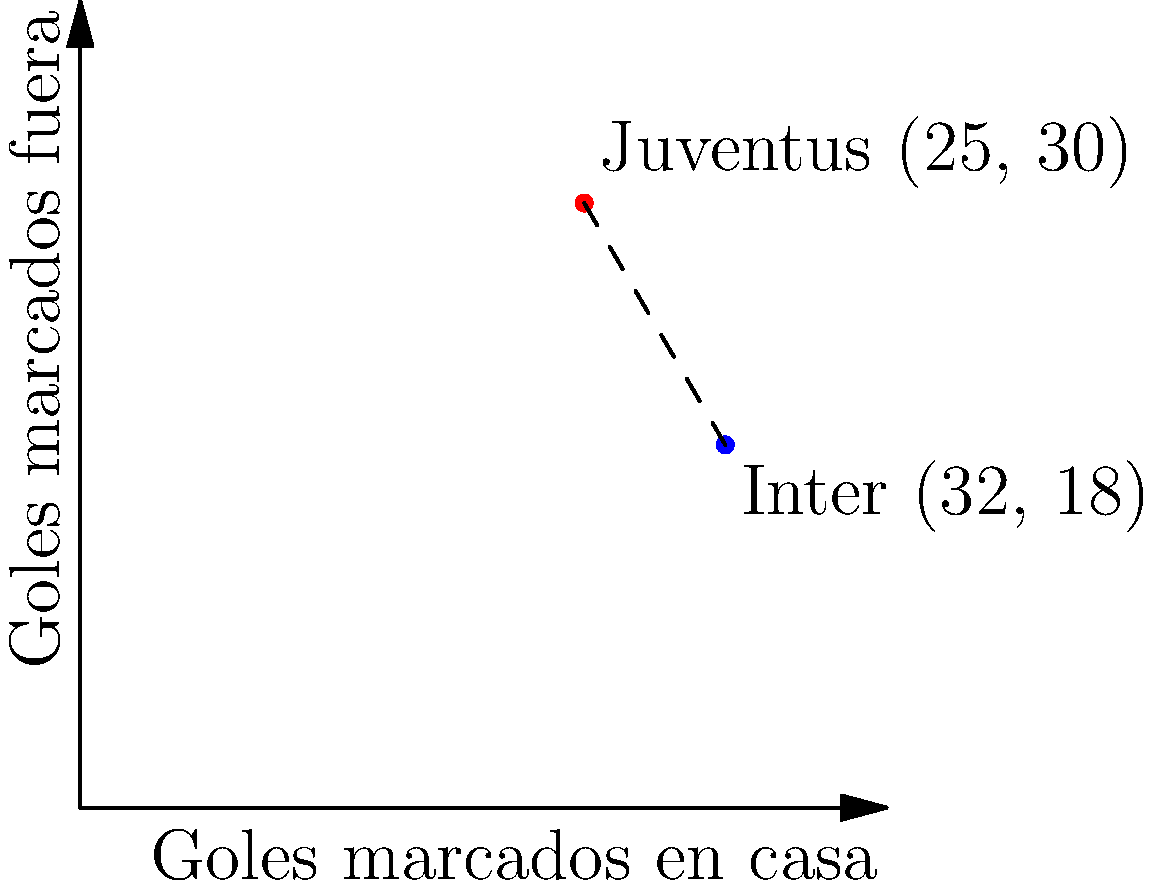En un plano cartesiano, se representan los goles marcados por dos equipos de la Serie A en la temporada 2019-2020. El eje x representa los goles marcados en casa, y el eje y los goles marcados fuera. La Juventus está representada por el punto (25, 30) y el Inter por el punto (32, 18). ¿Cuál es la distancia entre estos dos puntos, redondeada al entero más cercano? Esta distancia representa la diferencia en el patrón de goles entre los dos equipos. Para encontrar la distancia entre dos puntos en un plano cartesiano, usamos la fórmula de la distancia:

$$ d = \sqrt{(x_2 - x_1)^2 + (y_2 - y_1)^2} $$

Donde $(x_1, y_1)$ son las coordenadas del primer punto (Juventus) y $(x_2, y_2)$ son las coordenadas del segundo punto (Inter).

Paso 1: Identificar las coordenadas
Juventus: $(x_1, y_1) = (25, 30)$
Inter: $(x_2, y_2) = (32, 18)$

Paso 2: Aplicar la fórmula
$$ d = \sqrt{(32 - 25)^2 + (18 - 30)^2} $$

Paso 3: Calcular
$$ d = \sqrt{7^2 + (-12)^2} $$
$$ d = \sqrt{49 + 144} $$
$$ d = \sqrt{193} $$

Paso 4: Calcular y redondear
$$ d \approx 13.89 $$

Redondeando al entero más cercano, obtenemos 14.
Answer: 14 